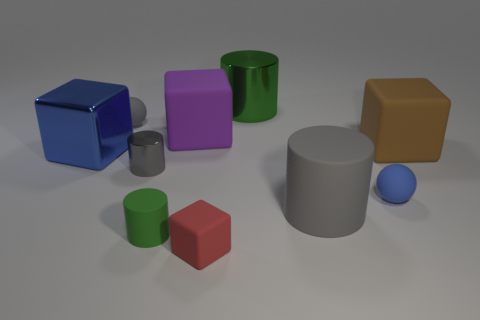Subtract all green matte cylinders. How many cylinders are left? 3 Subtract all red blocks. How many green cylinders are left? 2 Subtract all brown blocks. How many blocks are left? 3 Subtract 1 cylinders. How many cylinders are left? 3 Subtract all green blocks. Subtract all brown cylinders. How many blocks are left? 4 Subtract all spheres. How many objects are left? 8 Add 1 green shiny cylinders. How many green shiny cylinders are left? 2 Add 9 yellow cylinders. How many yellow cylinders exist? 9 Subtract 0 purple cylinders. How many objects are left? 10 Subtract all small rubber cubes. Subtract all blue spheres. How many objects are left? 8 